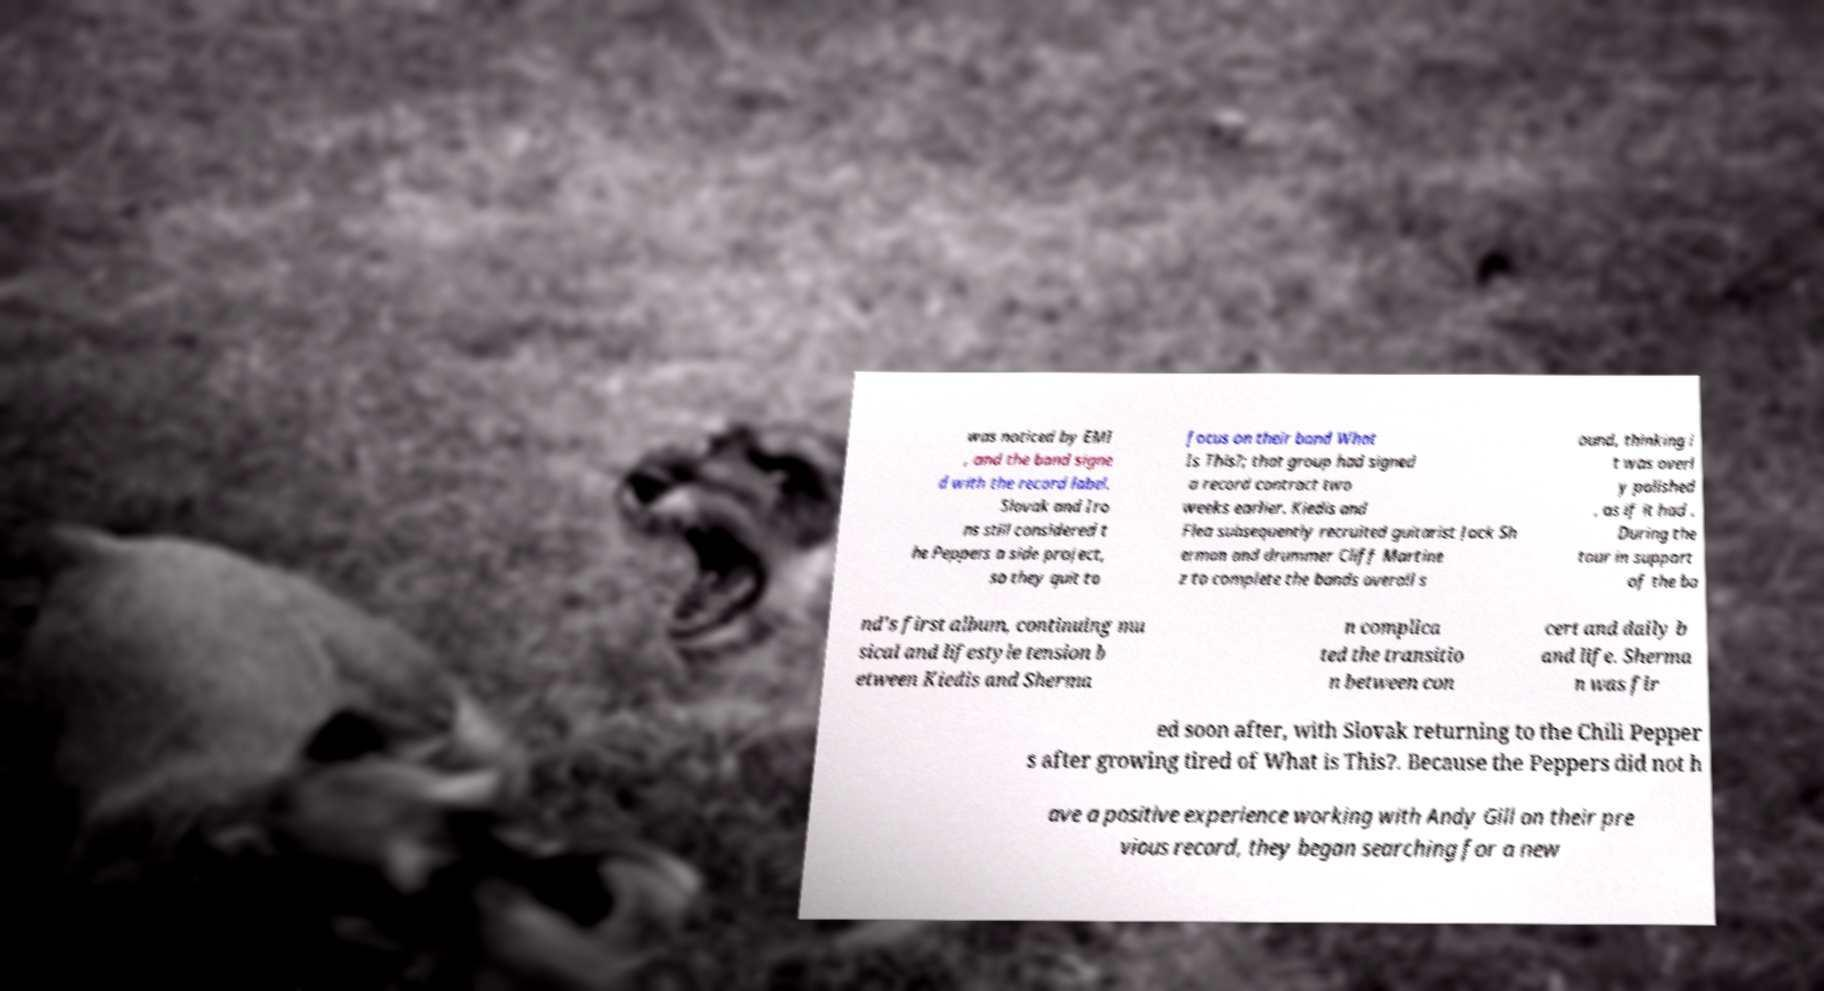Could you extract and type out the text from this image? was noticed by EMI , and the band signe d with the record label. Slovak and Iro ns still considered t he Peppers a side project, so they quit to focus on their band What Is This?; that group had signed a record contract two weeks earlier. Kiedis and Flea subsequently recruited guitarist Jack Sh erman and drummer Cliff Martine z to complete the bands overall s ound, thinking i t was overl y polished , as if it had . During the tour in support of the ba nd's first album, continuing mu sical and lifestyle tension b etween Kiedis and Sherma n complica ted the transitio n between con cert and daily b and life. Sherma n was fir ed soon after, with Slovak returning to the Chili Pepper s after growing tired of What is This?. Because the Peppers did not h ave a positive experience working with Andy Gill on their pre vious record, they began searching for a new 